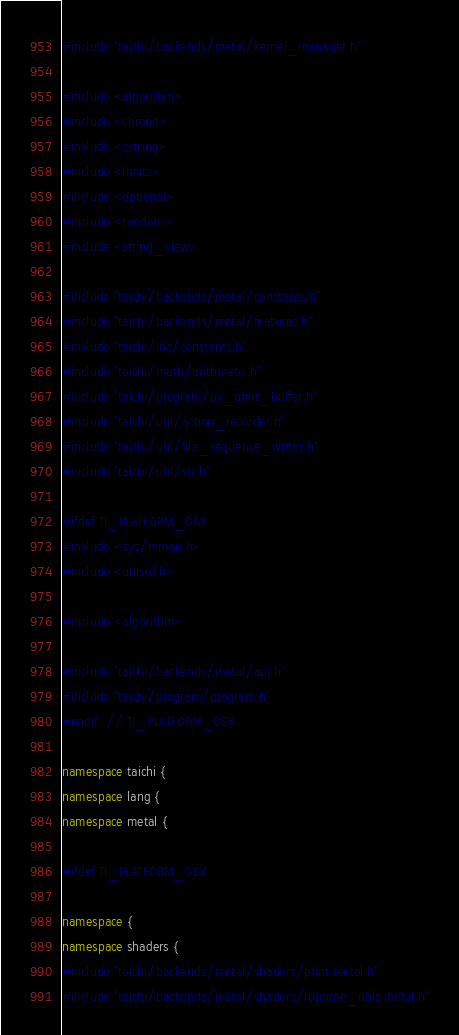Convert code to text. <code><loc_0><loc_0><loc_500><loc_500><_C++_>#include "taichi/backends/metal/kernel_manager.h"

#include <algorithm>
#include <chrono>
#include <cstring>
#include <limits>
#include <optional>
#include <random>
#include <string_view>

#include "taichi/backends/metal/constants.h"
#include "taichi/backends/metal/features.h"
#include "taichi/inc/constants.h"
#include "taichi/math/arithmetic.h"
#include "taichi/program/py_print_buffer.h"
#include "taichi/util/action_recorder.h"
#include "taichi/util/file_sequence_writer.h"
#include "taichi/util/str.h"

#ifdef TI_PLATFORM_OSX
#include <sys/mman.h>
#include <unistd.h>

#include <algorithm>

#include "taichi/backends/metal/api.h"
#include "taichi/program/program.h"
#endif  // TI_PLATFORM_OSX

namespace taichi {
namespace lang {
namespace metal {

#ifdef TI_PLATFORM_OSX

namespace {
namespace shaders {
#include "taichi/backends/metal/shaders/print.metal.h"
#include "taichi/backends/metal/shaders/runtime_utils.metal.h"</code> 